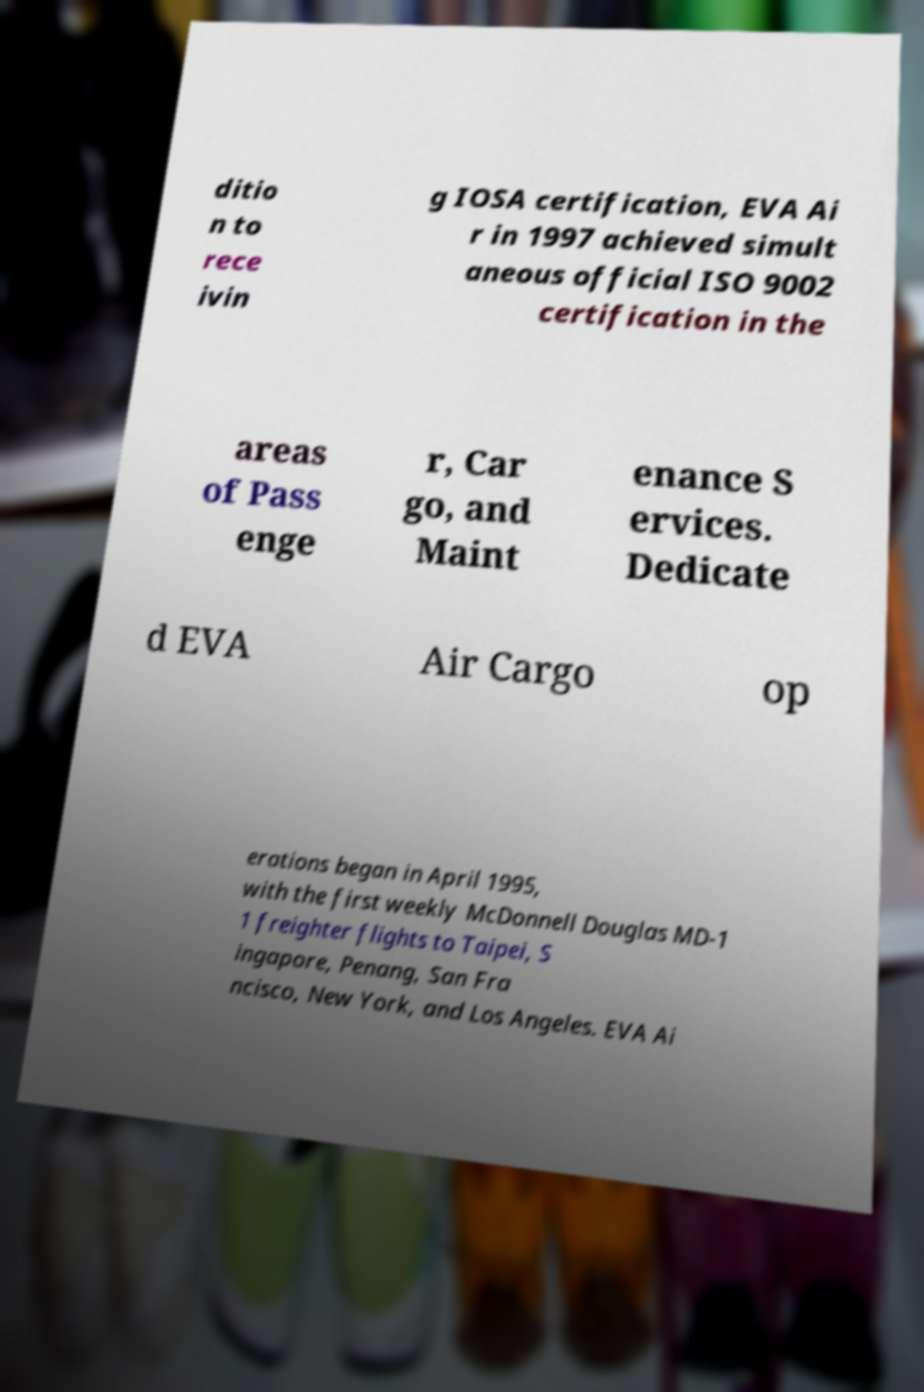There's text embedded in this image that I need extracted. Can you transcribe it verbatim? ditio n to rece ivin g IOSA certification, EVA Ai r in 1997 achieved simult aneous official ISO 9002 certification in the areas of Pass enge r, Car go, and Maint enance S ervices. Dedicate d EVA Air Cargo op erations began in April 1995, with the first weekly McDonnell Douglas MD-1 1 freighter flights to Taipei, S ingapore, Penang, San Fra ncisco, New York, and Los Angeles. EVA Ai 